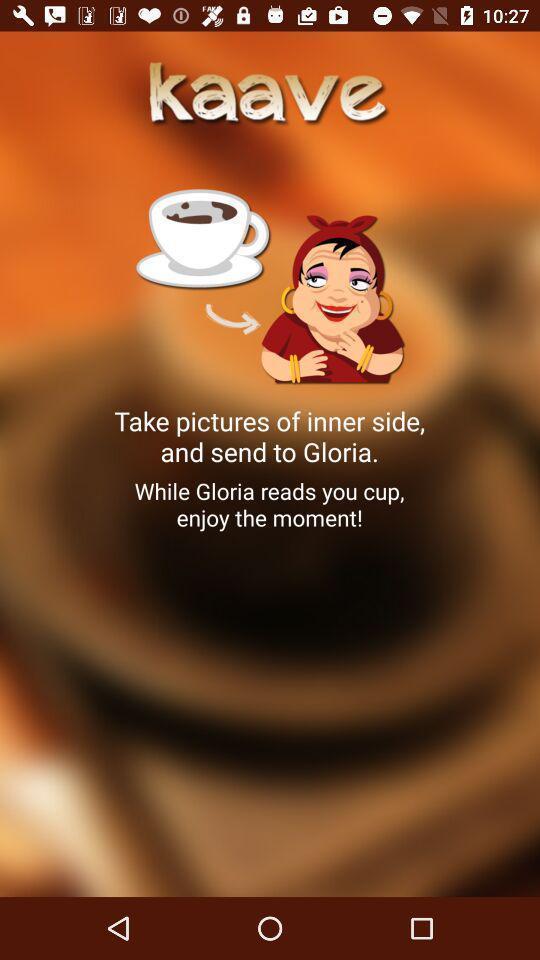Give me a narrative description of this picture. Welcome page. 